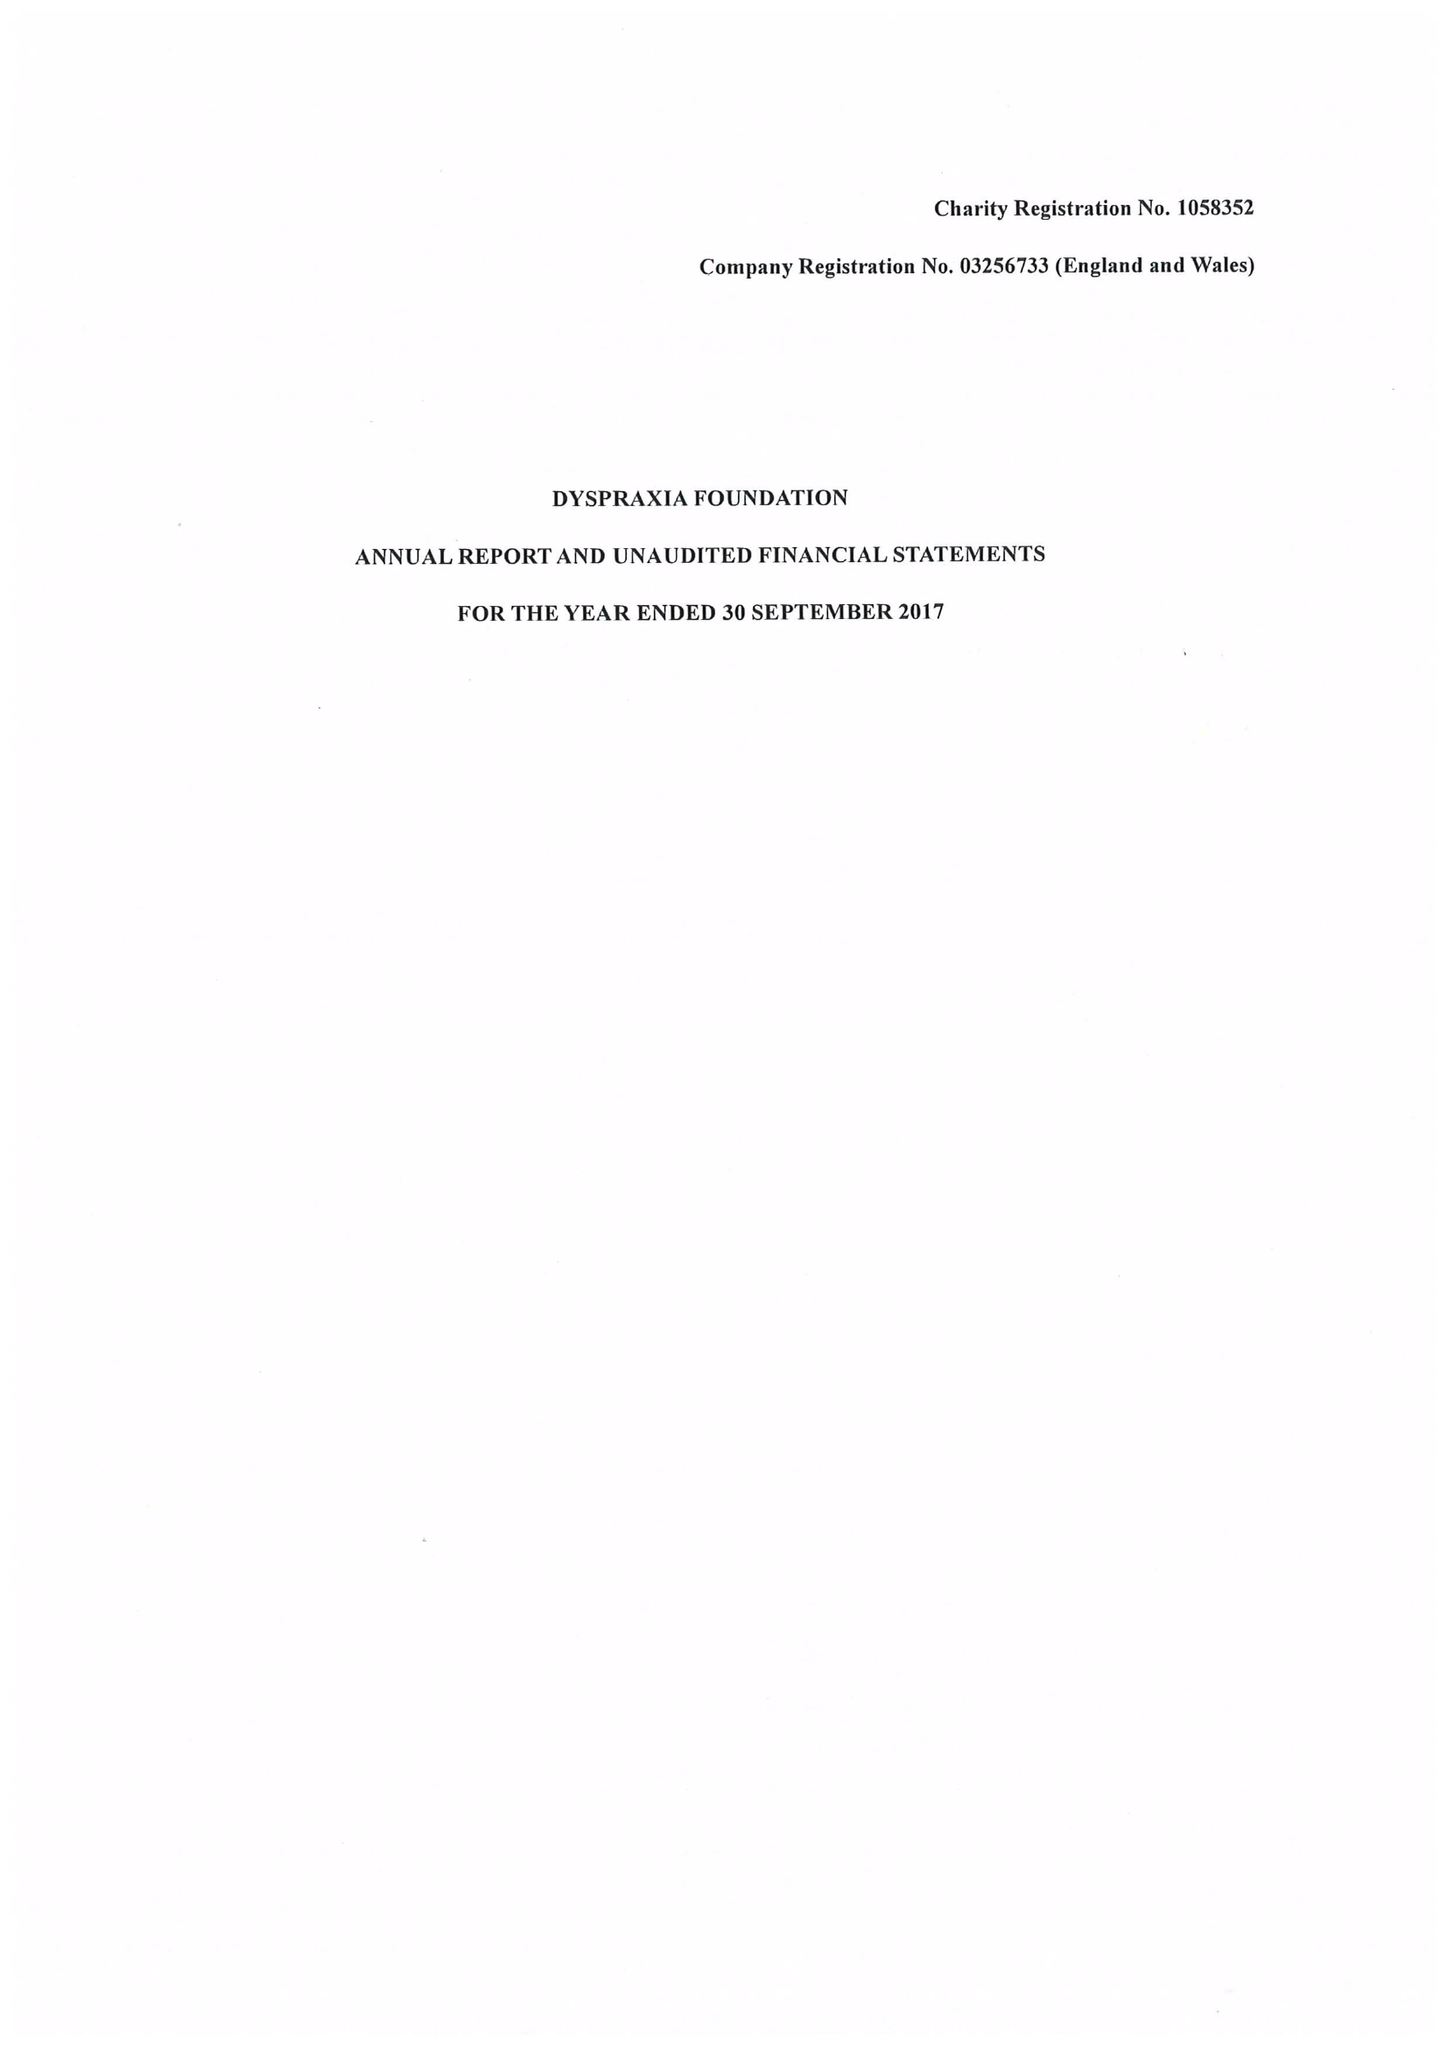What is the value for the report_date?
Answer the question using a single word or phrase. 2017-09-30 